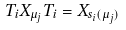Convert formula to latex. <formula><loc_0><loc_0><loc_500><loc_500>T _ { i } X _ { \mu _ { j } } T _ { i } = X _ { s _ { i } ( \mu _ { j } ) }</formula> 